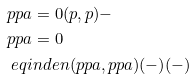Convert formula to latex. <formula><loc_0><loc_0><loc_500><loc_500>& p p a = 0 ( p , p ) - \\ & p p a = 0 \\ & \ e q i n d e n ( p p a , p p a ) ( - ) ( - )</formula> 